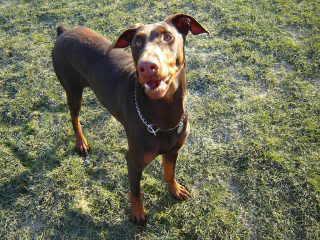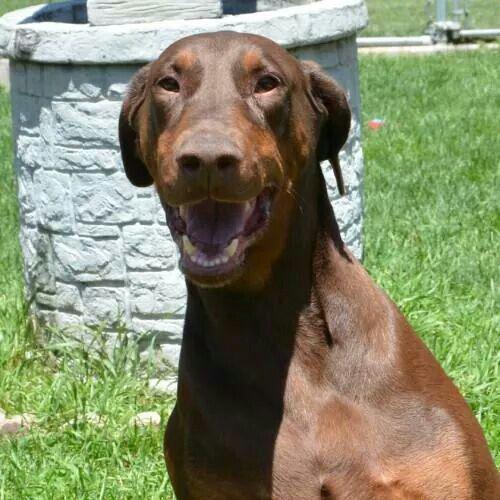The first image is the image on the left, the second image is the image on the right. Analyze the images presented: Is the assertion "There are at least three dogs in total." valid? Answer yes or no. No. The first image is the image on the left, the second image is the image on the right. Analyze the images presented: Is the assertion "The right image features two side-by-side forward-facing floppy-eared doberman with collar-like things around their shoulders." valid? Answer yes or no. No. 